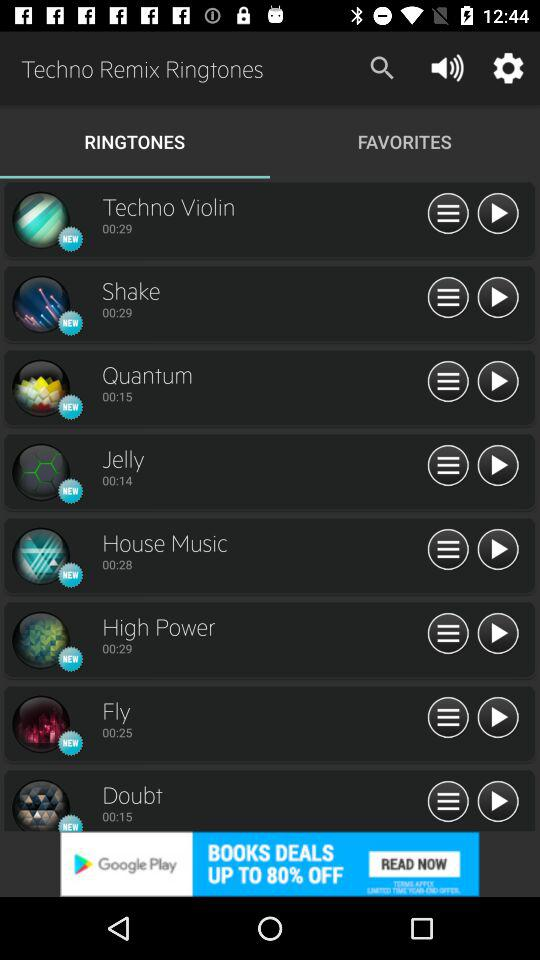What is the duration of the ringtone "Shake"? The duration is 29 seconds. 